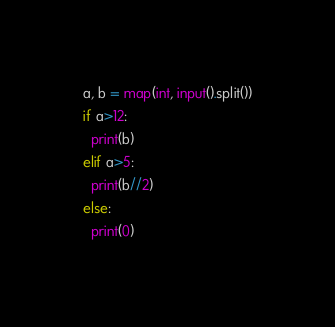Convert code to text. <code><loc_0><loc_0><loc_500><loc_500><_Python_>a, b = map(int, input().split())
if a>12:
  print(b)
elif a>5:
  print(b//2)
else:
  print(0)
</code> 